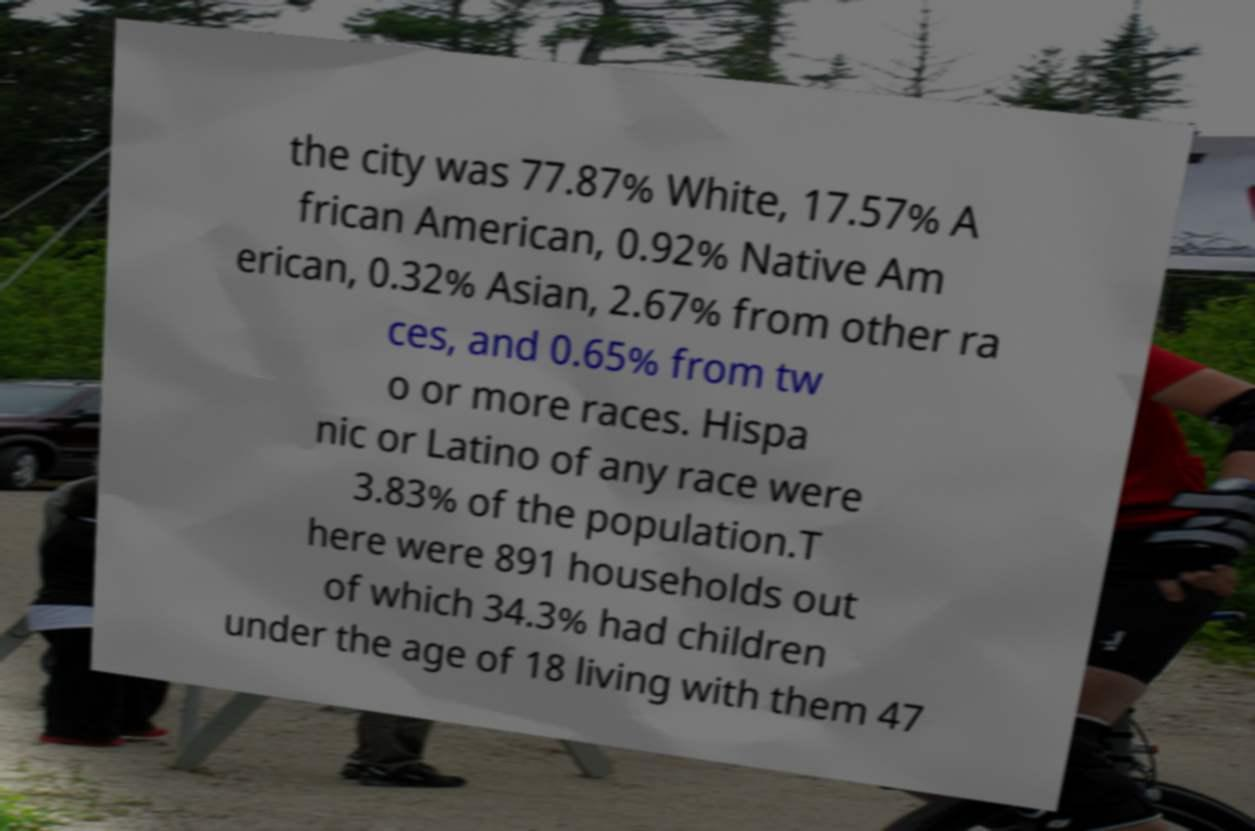Can you read and provide the text displayed in the image?This photo seems to have some interesting text. Can you extract and type it out for me? the city was 77.87% White, 17.57% A frican American, 0.92% Native Am erican, 0.32% Asian, 2.67% from other ra ces, and 0.65% from tw o or more races. Hispa nic or Latino of any race were 3.83% of the population.T here were 891 households out of which 34.3% had children under the age of 18 living with them 47 